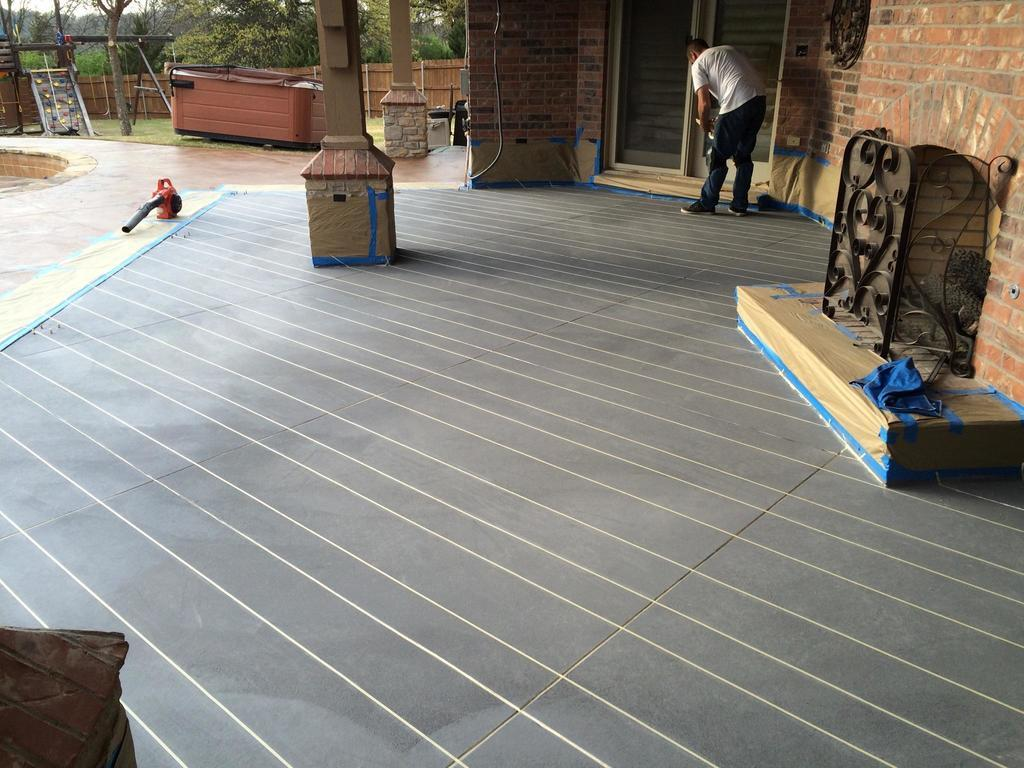What is the main subject in the middle of the image? There is a man standing in the middle of the image. What can be seen behind the man? There is a building behind the man. What is visible beyond the building? There are trees visible behind the building. What type of barrier is present in the image? There is fencing in the image. What type of current is flowing through the man's shoe in the image? There is no current or shoe present in the image; it only features a man, a building, trees, and fencing. 